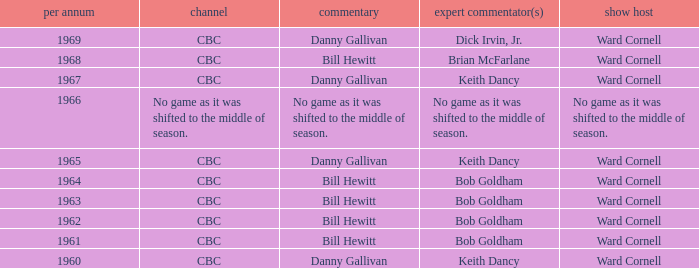Who did the play-by-play with studio host Ward Cornell and color commentator Bob Goldham? Bill Hewitt, Bill Hewitt, Bill Hewitt, Bill Hewitt. 